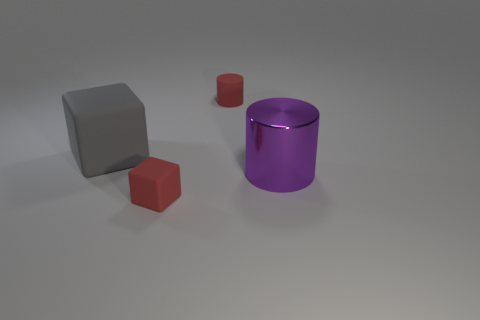What shape is the big object that is in front of the block that is left of the matte cube that is right of the big matte cube?
Your answer should be compact. Cylinder. The thing that is behind the red rubber block and in front of the gray rubber block is made of what material?
Your answer should be compact. Metal. How many red objects have the same size as the red matte cylinder?
Provide a short and direct response. 1. How many matte objects are small cubes or big gray things?
Your answer should be compact. 2. What is the material of the small cylinder?
Your answer should be compact. Rubber. How many rubber blocks are in front of the gray thing?
Make the answer very short. 1. Is the material of the tiny red object that is in front of the large rubber block the same as the tiny cylinder?
Keep it short and to the point. Yes. What number of small matte things are the same shape as the big matte thing?
Keep it short and to the point. 1. What number of small things are gray matte things or rubber cylinders?
Your answer should be very brief. 1. Is the color of the tiny matte thing behind the purple thing the same as the small block?
Keep it short and to the point. Yes. 